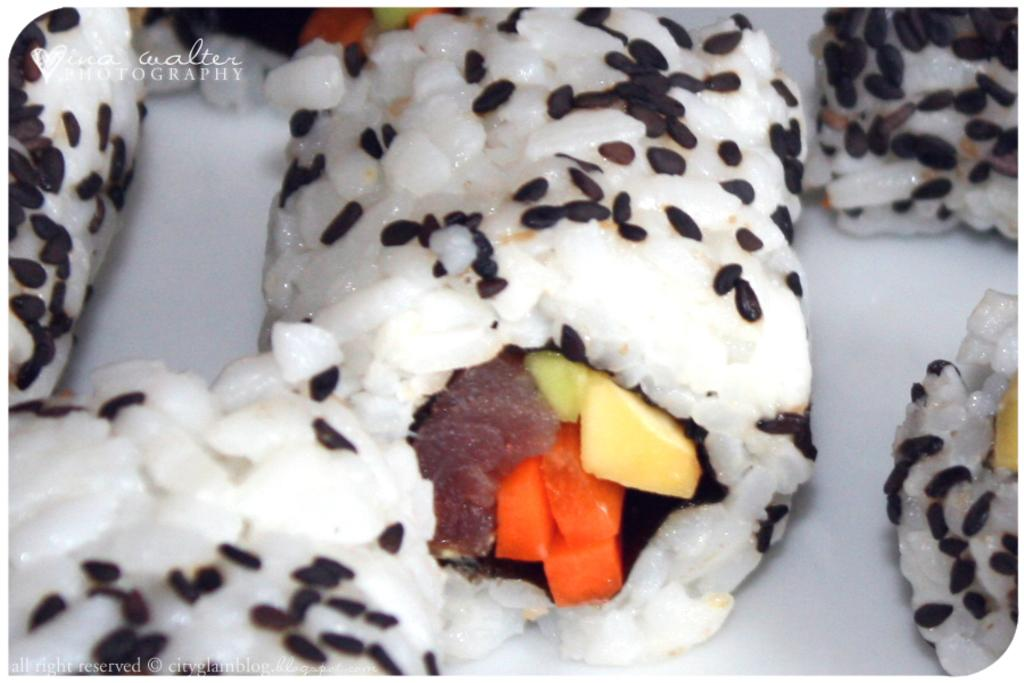What is the main subject of the image? There is a food item on a plate in the image. Can you describe the food item in more detail? Unfortunately, the specific food item cannot be determined from the provided facts. Is there any additional context or objects visible in the image? No additional context or objects are mentioned in the provided facts. How many roses are on the plate with the food item in the image? There is no mention of roses in the provided facts, so it cannot be determined if any are present in the image. 